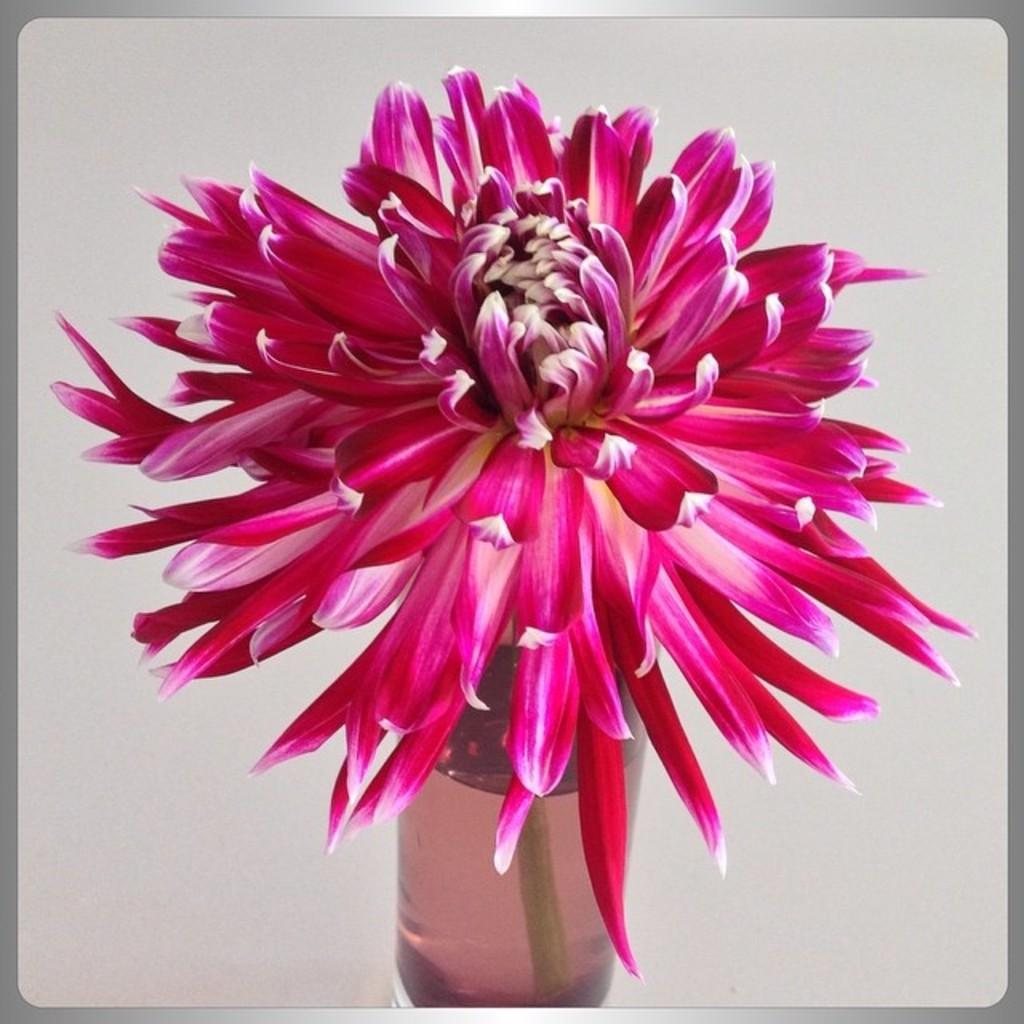What is present in the image that can hold liquid? There is a glass in the image. What is inside the glass? There is a flower in the glass. How much dust is visible on the flower in the image? There is no mention of dust in the image, so it cannot be determined how much dust is visible on the flower. 